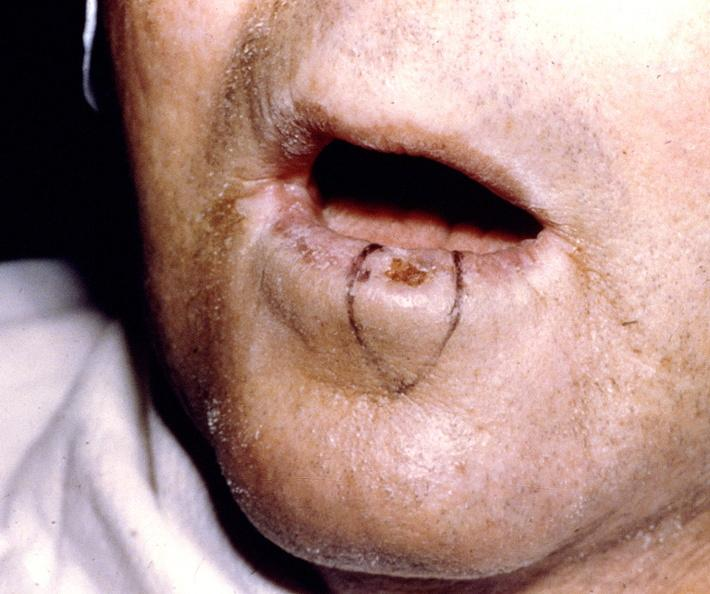what does this image show?
Answer the question using a single word or phrase. Squamous cell carcinoma 